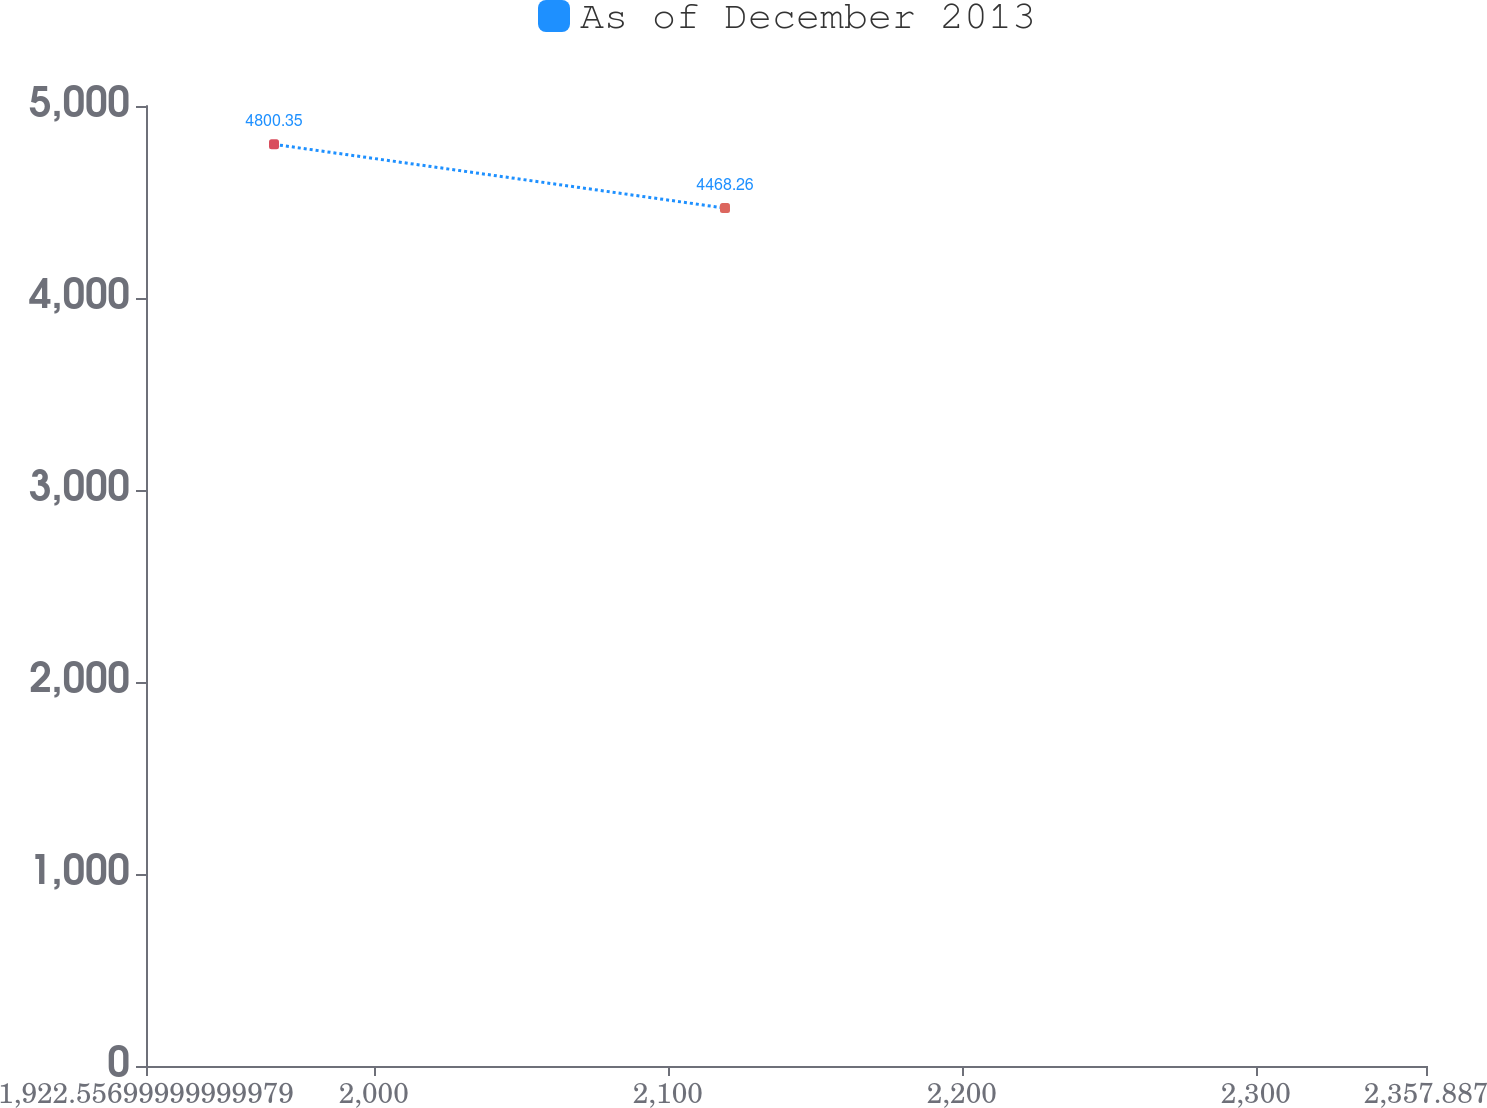Convert chart. <chart><loc_0><loc_0><loc_500><loc_500><line_chart><ecel><fcel>As of December 2013<nl><fcel>1966.09<fcel>4800.35<nl><fcel>2119.47<fcel>4468.26<nl><fcel>2401.42<fcel>1478.37<nl></chart> 